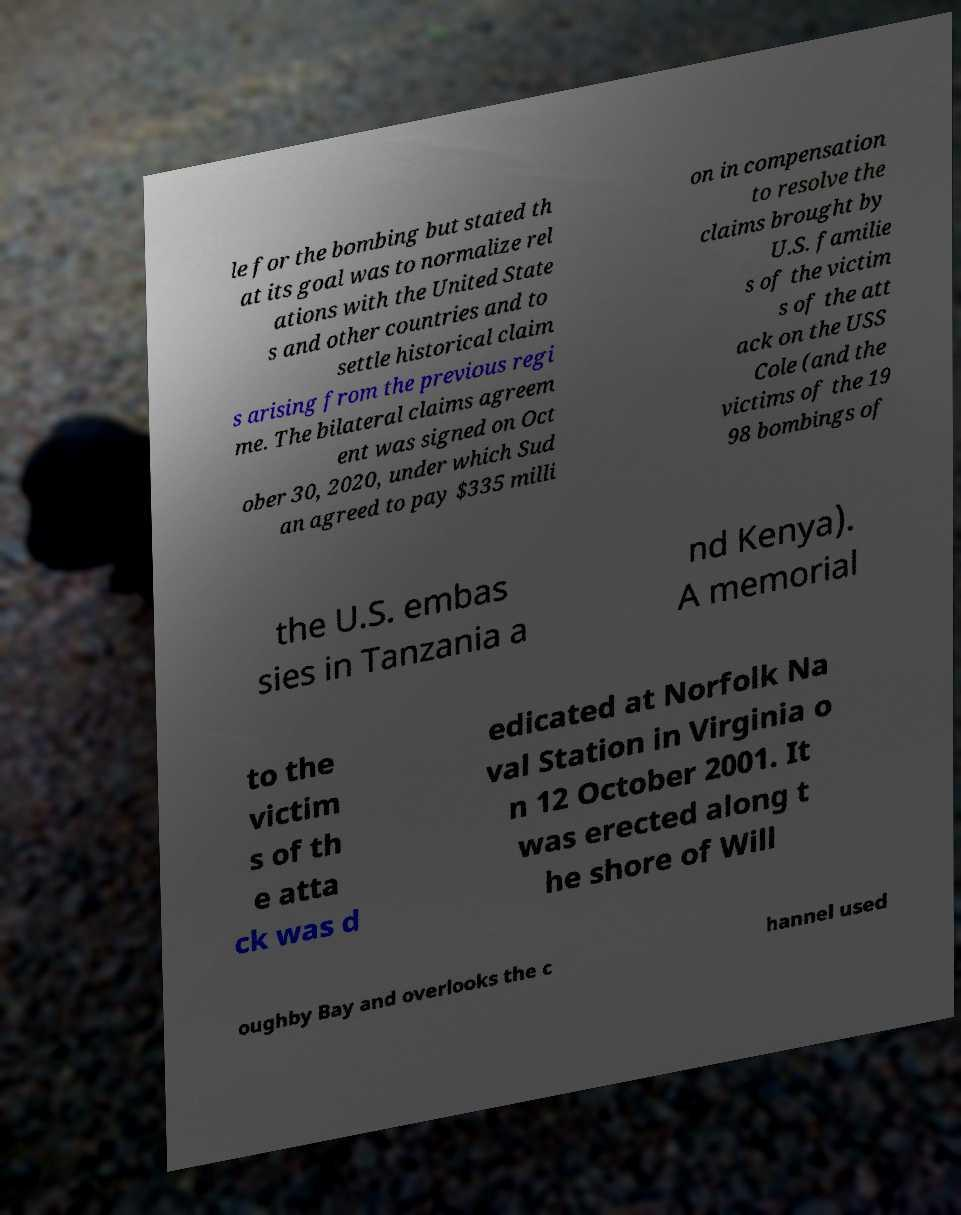Could you extract and type out the text from this image? le for the bombing but stated th at its goal was to normalize rel ations with the United State s and other countries and to settle historical claim s arising from the previous regi me. The bilateral claims agreem ent was signed on Oct ober 30, 2020, under which Sud an agreed to pay $335 milli on in compensation to resolve the claims brought by U.S. familie s of the victim s of the att ack on the USS Cole (and the victims of the 19 98 bombings of the U.S. embas sies in Tanzania a nd Kenya). A memorial to the victim s of th e atta ck was d edicated at Norfolk Na val Station in Virginia o n 12 October 2001. It was erected along t he shore of Will oughby Bay and overlooks the c hannel used 